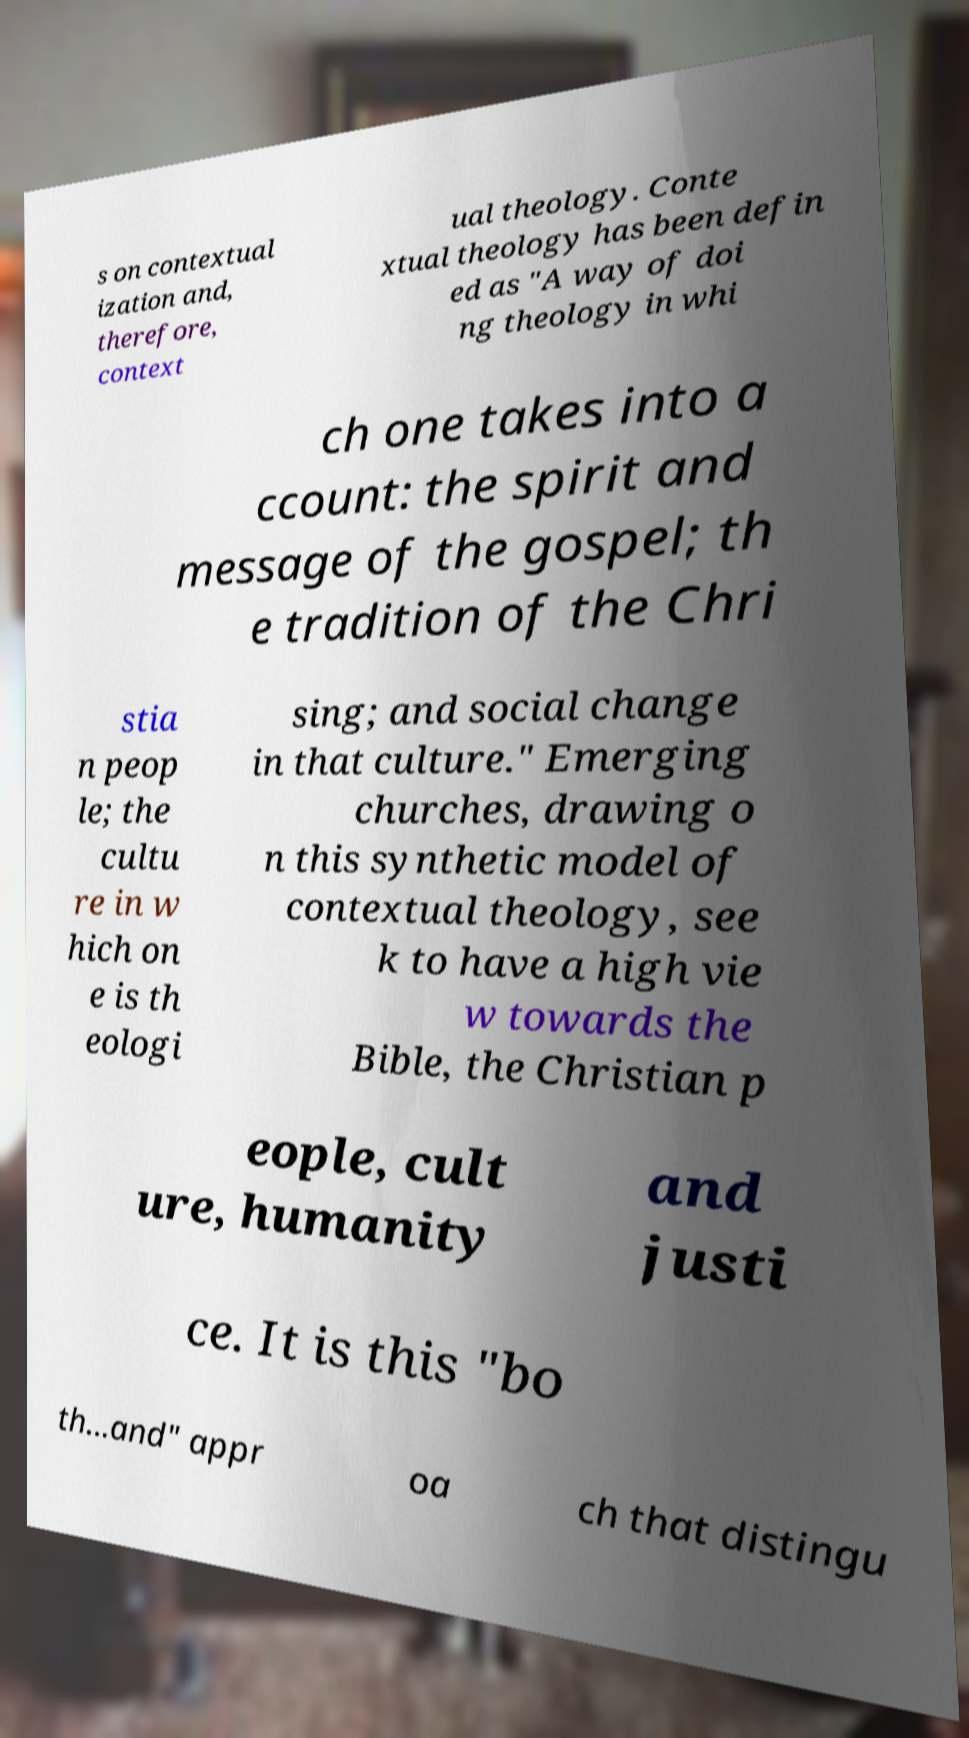Could you extract and type out the text from this image? s on contextual ization and, therefore, context ual theology. Conte xtual theology has been defin ed as "A way of doi ng theology in whi ch one takes into a ccount: the spirit and message of the gospel; th e tradition of the Chri stia n peop le; the cultu re in w hich on e is th eologi sing; and social change in that culture." Emerging churches, drawing o n this synthetic model of contextual theology, see k to have a high vie w towards the Bible, the Christian p eople, cult ure, humanity and justi ce. It is this "bo th...and" appr oa ch that distingu 